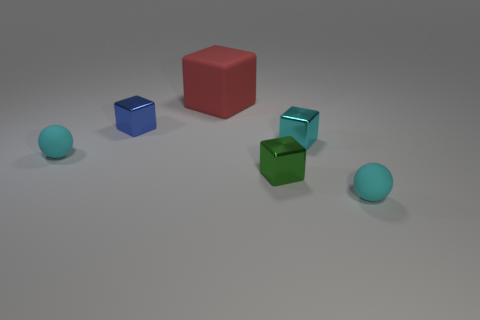Subtract 2 cubes. How many cubes are left? 2 Subtract all gray cubes. Subtract all blue cylinders. How many cubes are left? 4 Add 1 green shiny objects. How many objects exist? 7 Subtract all balls. How many objects are left? 4 Subtract 0 brown spheres. How many objects are left? 6 Subtract all small balls. Subtract all cyan spheres. How many objects are left? 2 Add 2 small cyan shiny blocks. How many small cyan shiny blocks are left? 3 Add 5 tiny cyan rubber objects. How many tiny cyan rubber objects exist? 7 